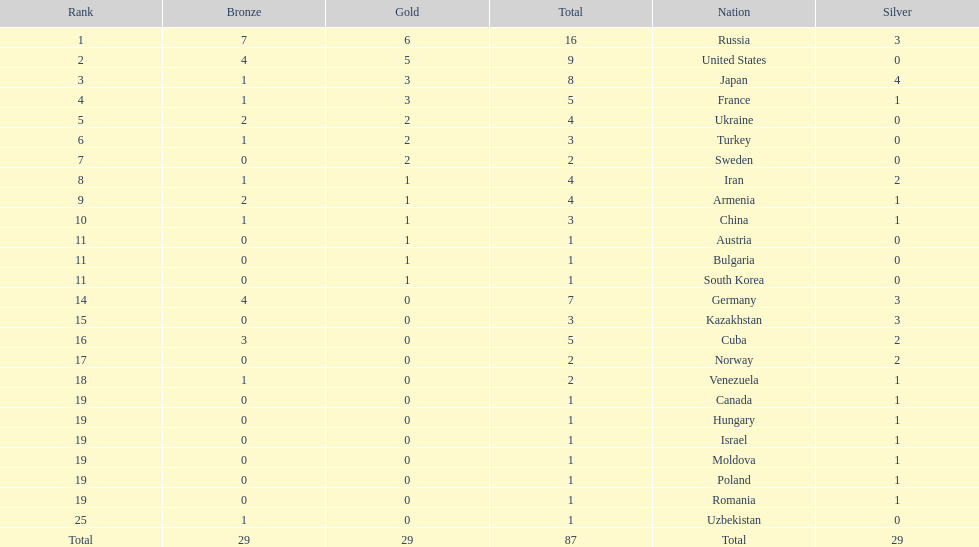Which nations are there? Russia, 6, United States, 5, Japan, 3, France, 3, Ukraine, 2, Turkey, 2, Sweden, 2, Iran, 1, Armenia, 1, China, 1, Austria, 1, Bulgaria, 1, South Korea, 1, Germany, 0, Kazakhstan, 0, Cuba, 0, Norway, 0, Venezuela, 0, Canada, 0, Hungary, 0, Israel, 0, Moldova, 0, Poland, 0, Romania, 0, Uzbekistan, 0. Which nations won gold? Russia, 6, United States, 5, Japan, 3, France, 3, Ukraine, 2, Turkey, 2, Sweden, 2, Iran, 1, Armenia, 1, China, 1, Austria, 1, Bulgaria, 1, South Korea, 1. How many golds did united states win? United States, 5. Which country has more than 5 gold medals? Russia, 6. What country is it? Russia. 